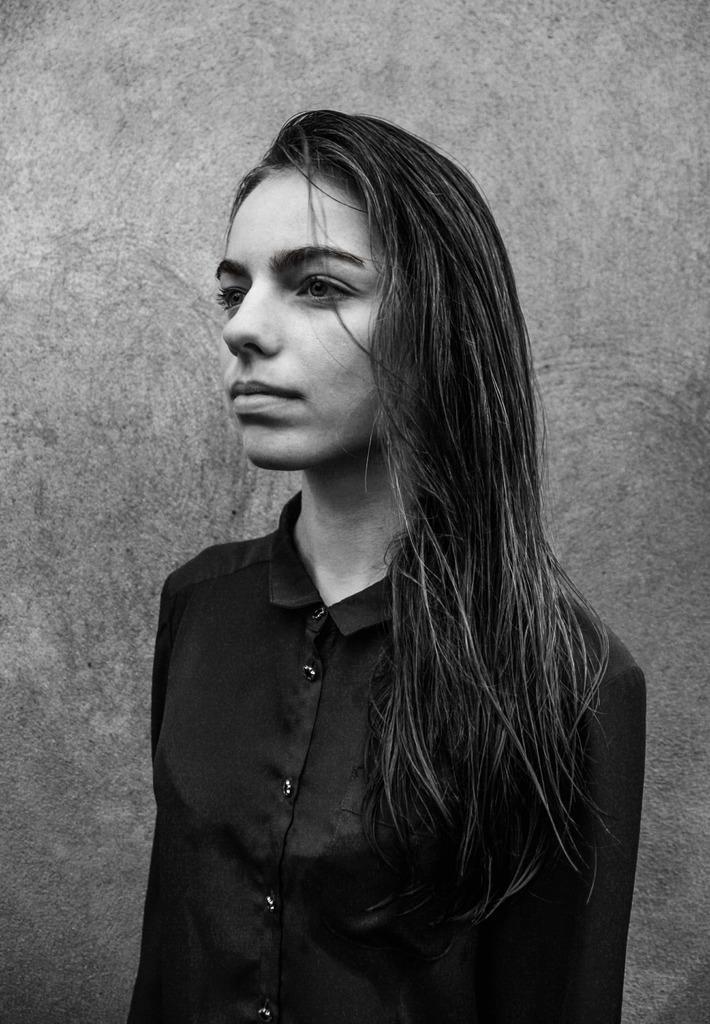Can you describe this image briefly? There is a girl standing in the foreground area of the image and a wall in the background. 